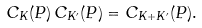<formula> <loc_0><loc_0><loc_500><loc_500>C _ { K } ( P ) \, C _ { K ^ { \prime } } ( P ) = C _ { K + K ^ { \prime } } ( P ) .</formula> 